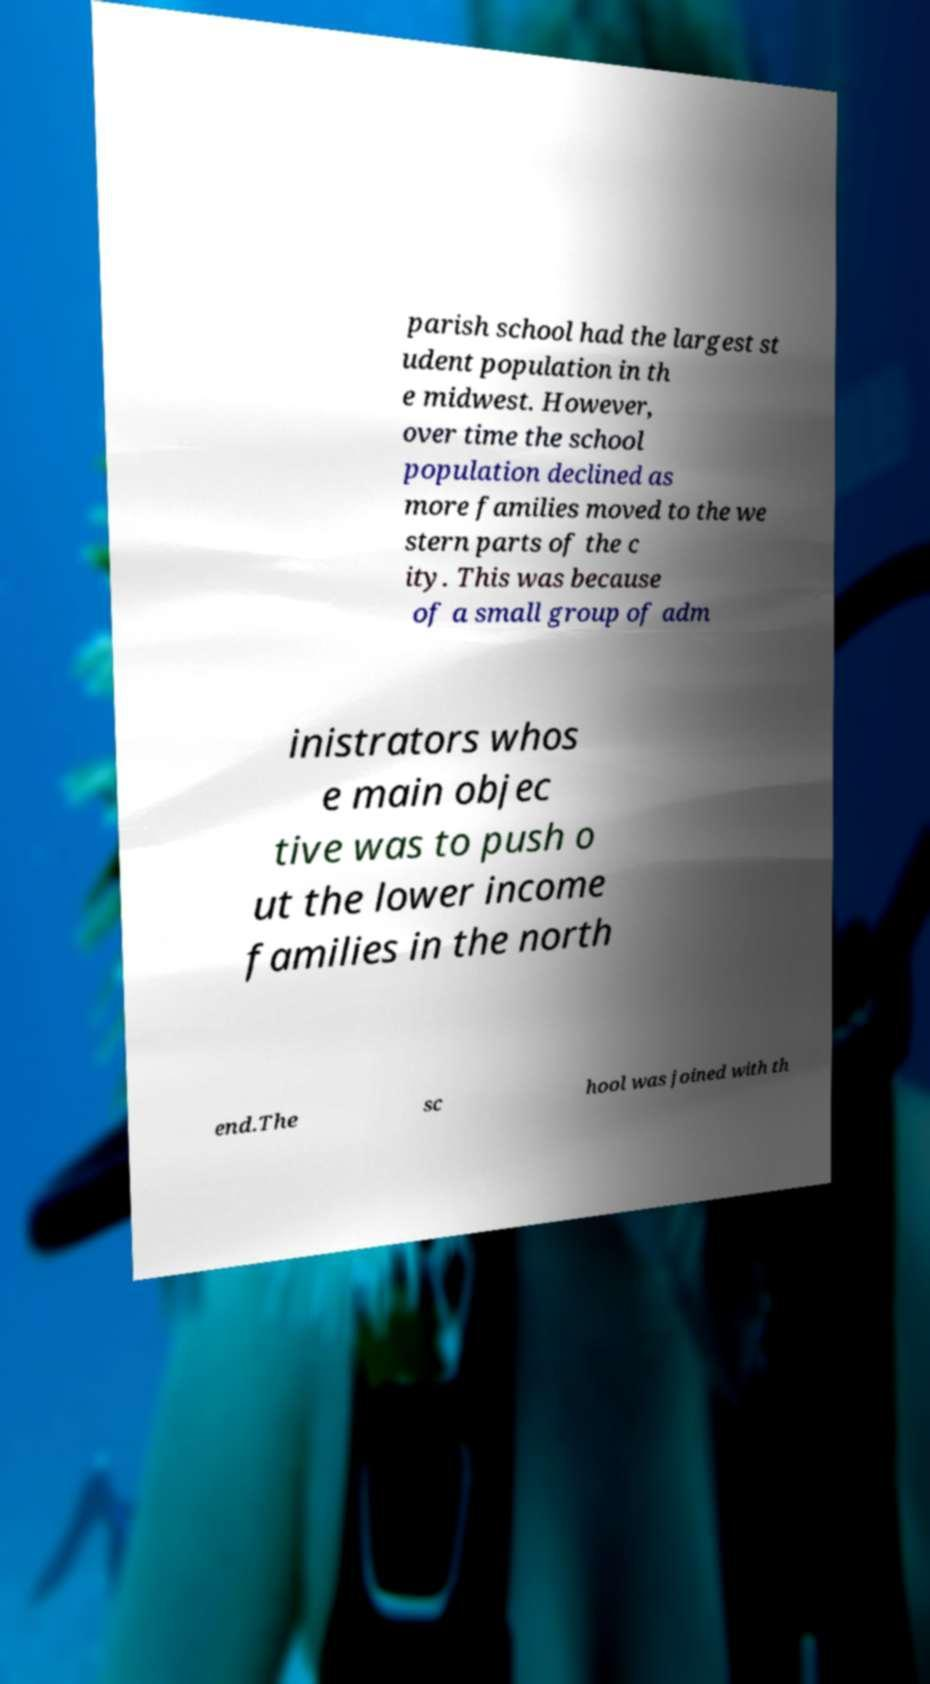What messages or text are displayed in this image? I need them in a readable, typed format. parish school had the largest st udent population in th e midwest. However, over time the school population declined as more families moved to the we stern parts of the c ity. This was because of a small group of adm inistrators whos e main objec tive was to push o ut the lower income families in the north end.The sc hool was joined with th 